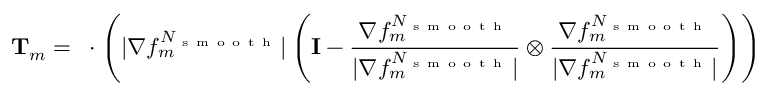Convert formula to latex. <formula><loc_0><loc_0><loc_500><loc_500>T _ { m } = \nabla \cdot \left ( | \nabla f _ { m } ^ { N _ { s m o o t h } } | \left ( I - \frac { \nabla f _ { m } ^ { N _ { s m o o t h } } } { | \nabla f _ { m } ^ { N _ { s m o o t h } } | } \otimes \frac { \nabla f _ { m } ^ { N _ { s m o o t h } } } { | \nabla f _ { m } ^ { N _ { s m o o t h } } | } \right ) \right )</formula> 